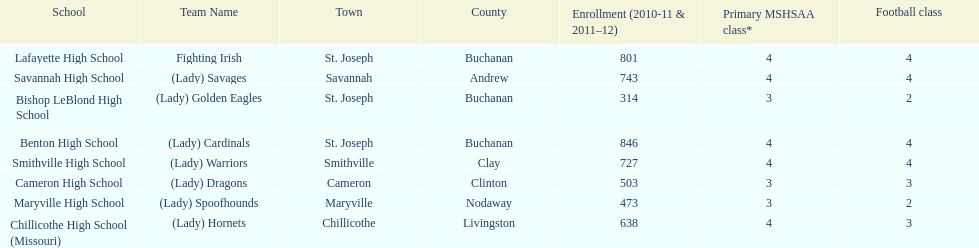How many are enrolled at each school? Benton High School, 846, Bishop LeBlond High School, 314, Cameron High School, 503, Chillicothe High School (Missouri), 638, Lafayette High School, 801, Maryville High School, 473, Savannah High School, 743, Smithville High School, 727. Which school has at only three football classes? Cameron High School, 3, Chillicothe High School (Missouri), 3. Which school has 638 enrolled and 3 football classes? Chillicothe High School (Missouri). 